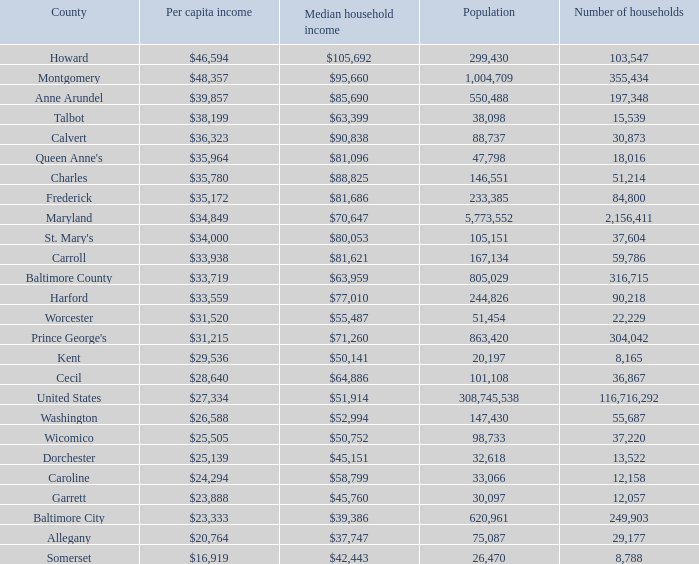What is the per capita earnings for washington county? $26,588. 